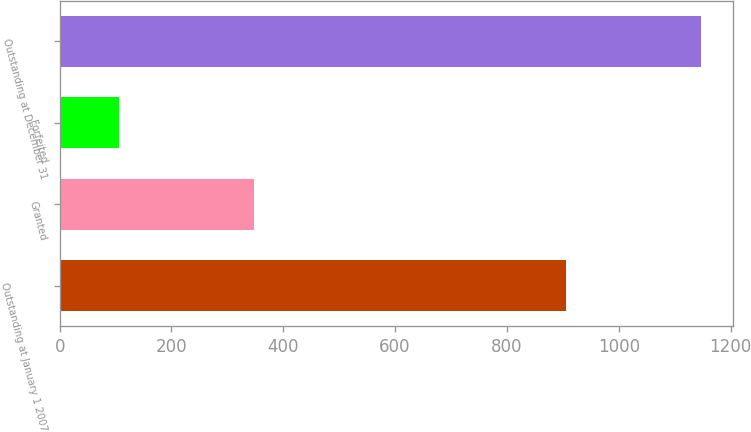Convert chart to OTSL. <chart><loc_0><loc_0><loc_500><loc_500><bar_chart><fcel>Outstanding at January 1 2007<fcel>Granted<fcel>Forfeited<fcel>Outstanding at December 31<nl><fcel>905<fcel>348<fcel>106<fcel>1147<nl></chart> 